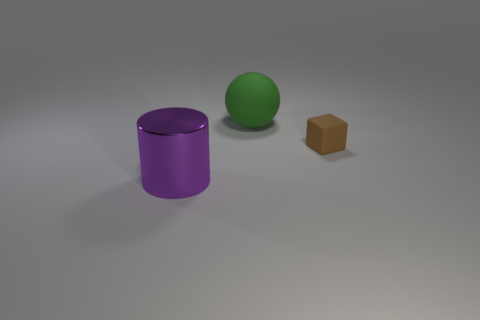The thing that is on the left side of the brown thing and right of the large cylinder is what color?
Ensure brevity in your answer.  Green. The matte block has what color?
Make the answer very short. Brown. How big is the matte cube that is in front of the big sphere?
Keep it short and to the point. Small. There is a green sphere that is the same size as the purple cylinder; what material is it?
Keep it short and to the point. Rubber. Are there more green spheres than small green cylinders?
Give a very brief answer. Yes. How big is the thing on the right side of the rubber object that is to the left of the small brown thing?
Your response must be concise. Small. There is a purple thing that is the same size as the green rubber sphere; what is its shape?
Offer a terse response. Cylinder. There is a rubber thing behind the thing that is on the right side of the large object behind the brown matte cube; what shape is it?
Make the answer very short. Sphere. What number of tiny blue rubber things are there?
Your answer should be very brief. 0. Are there any big purple metal cylinders behind the cylinder?
Provide a short and direct response. No. 